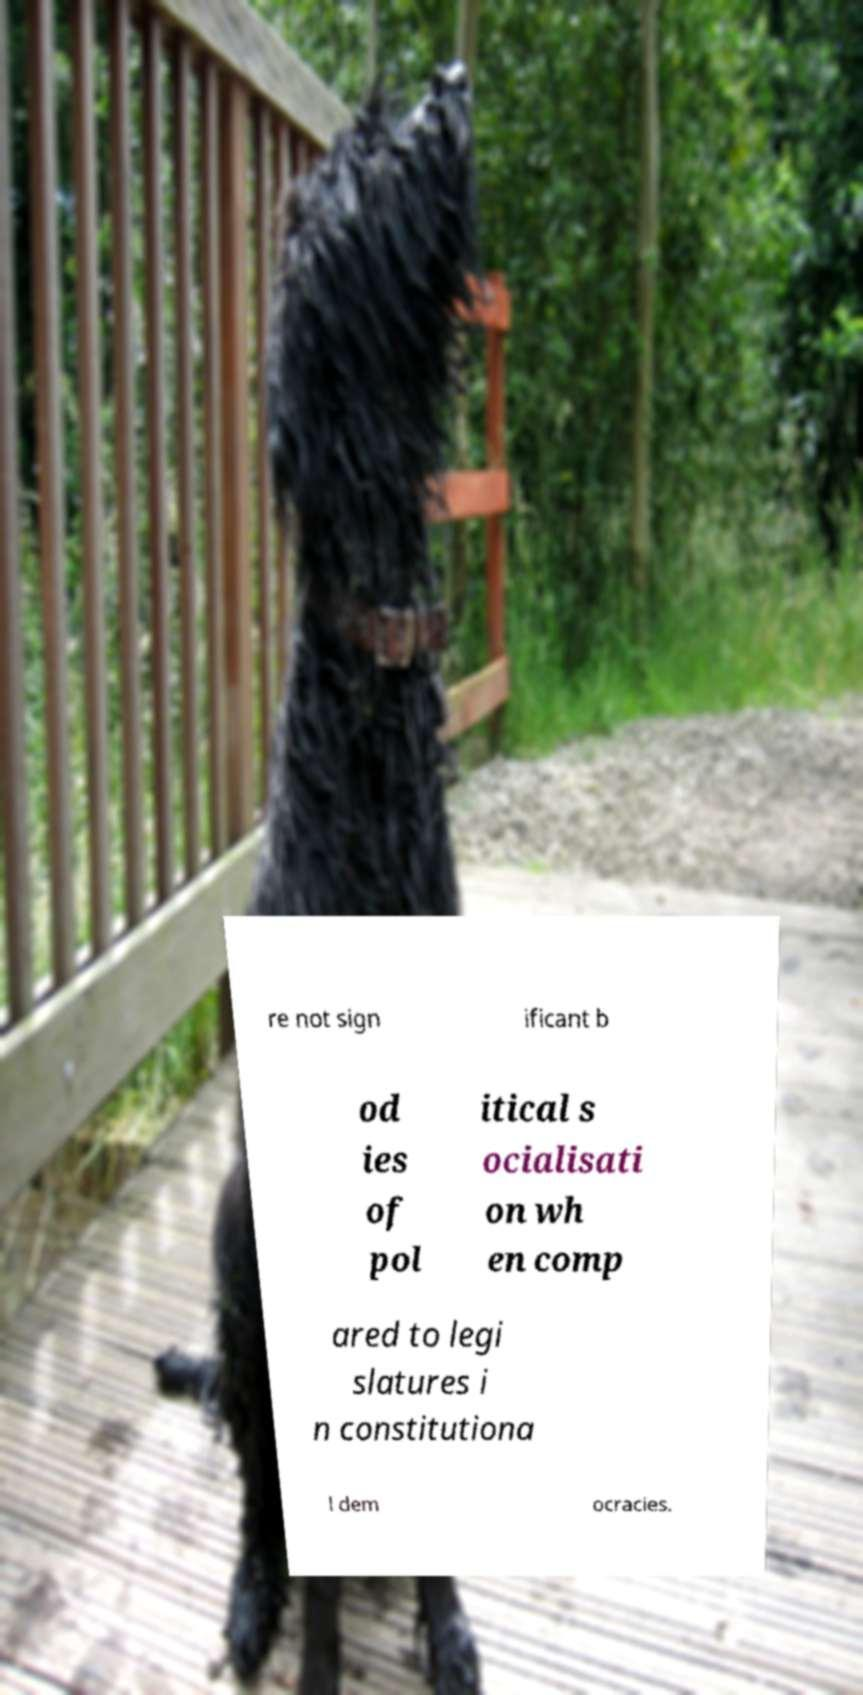Could you extract and type out the text from this image? re not sign ificant b od ies of pol itical s ocialisati on wh en comp ared to legi slatures i n constitutiona l dem ocracies. 